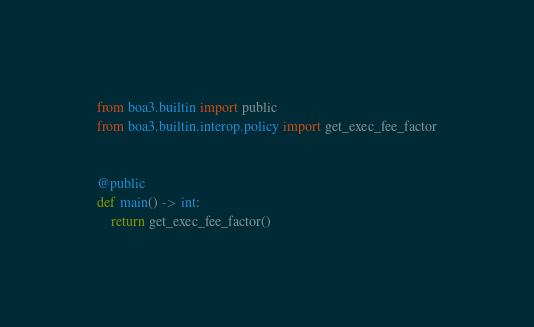<code> <loc_0><loc_0><loc_500><loc_500><_Python_>from boa3.builtin import public
from boa3.builtin.interop.policy import get_exec_fee_factor


@public
def main() -> int:
    return get_exec_fee_factor()
</code> 